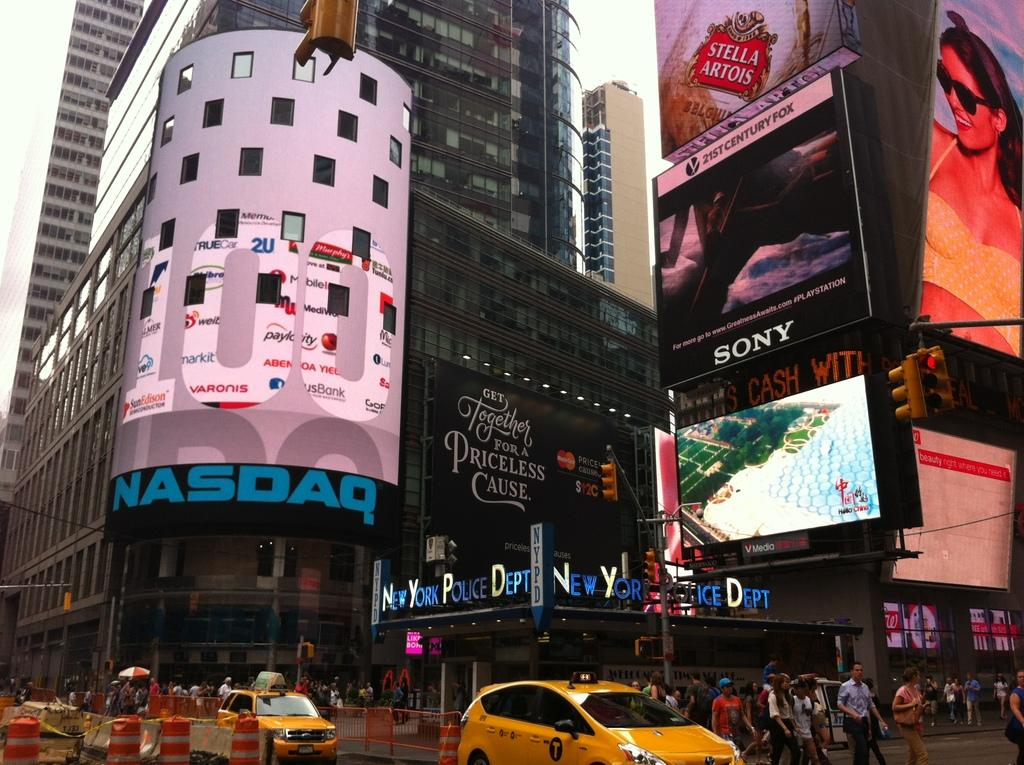<image>
Provide a brief description of the given image. A city scene that shows a large ad for Stella Artois. 